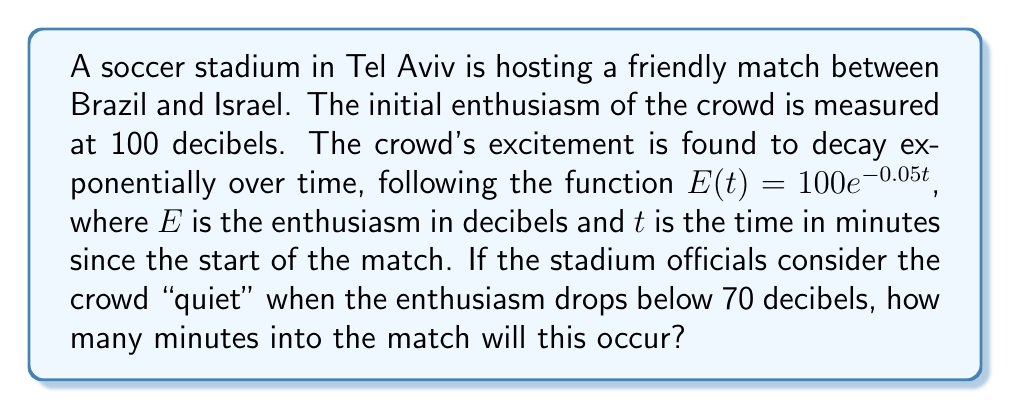Could you help me with this problem? To solve this problem, we need to use the given exponential function and determine when it reaches 70 decibels. Let's approach this step-by-step:

1) We're given the function $E(t) = 100e^{-0.05t}$

2) We want to find $t$ when $E(t) = 70$

3) Let's set up the equation:
   $70 = 100e^{-0.05t}$

4) Divide both sides by 100:
   $0.7 = e^{-0.05t}$

5) Take the natural logarithm of both sides:
   $\ln(0.7) = \ln(e^{-0.05t})$

6) Simplify the right side using the properties of logarithms:
   $\ln(0.7) = -0.05t$

7) Divide both sides by -0.05:
   $\frac{\ln(0.7)}{-0.05} = t$

8) Calculate the value:
   $t \approx 7.13$ minutes

Therefore, the crowd will be considered "quiet" after approximately 7.13 minutes.
Answer: The crowd will be considered "quiet" after approximately 7.13 minutes. 